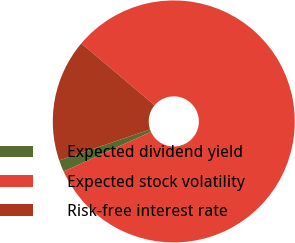<chart> <loc_0><loc_0><loc_500><loc_500><pie_chart><fcel>Expected dividend yield<fcel>Expected stock volatility<fcel>Risk-free interest rate<nl><fcel>1.57%<fcel>82.05%<fcel>16.38%<nl></chart> 